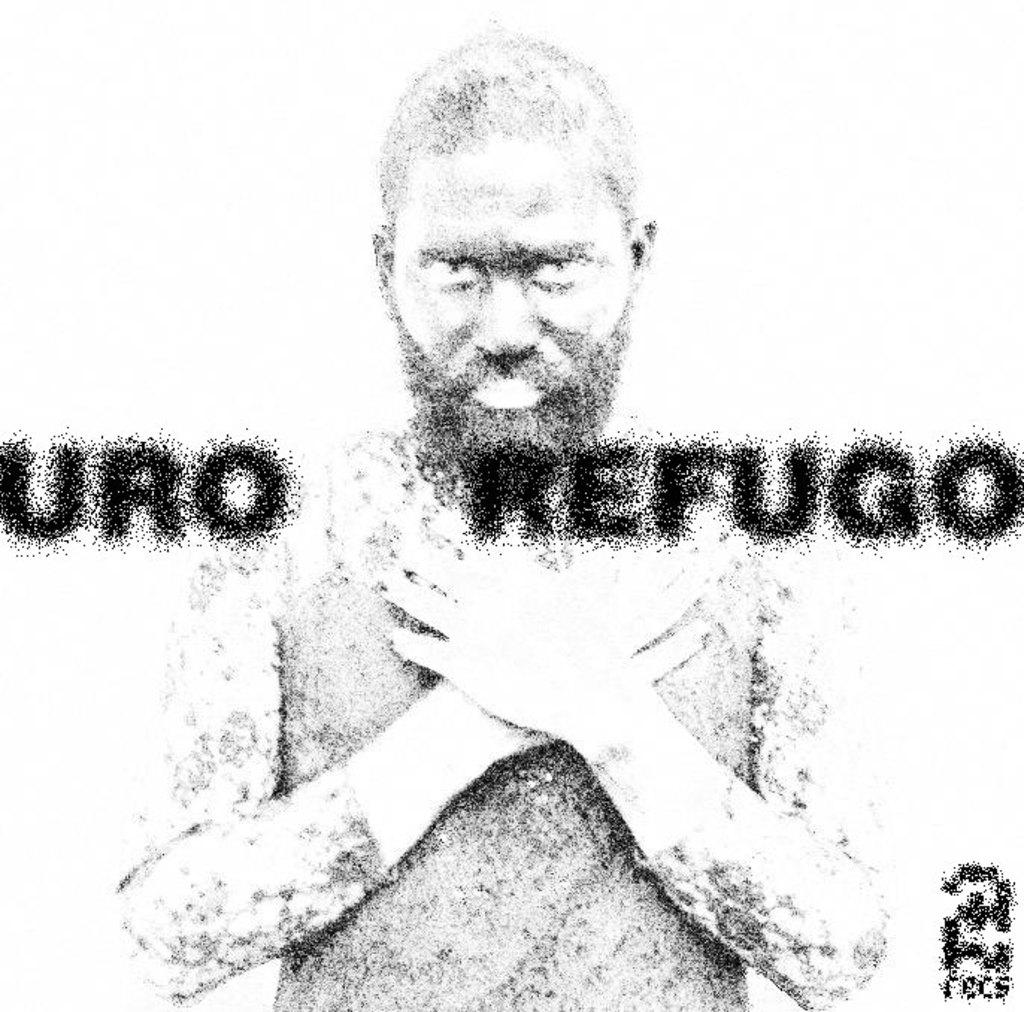What is the main subject of the image? There is a sketch of a person in the image. Are there any words or letters on the image? Yes, there is text on the image. What color is the background of the image? The background of the image is white. How many cans are visible in the image? There are no cans present in the image. Can you describe the person's breathing pattern in the image? The image is a sketch and does not depict a person's breathing pattern. 